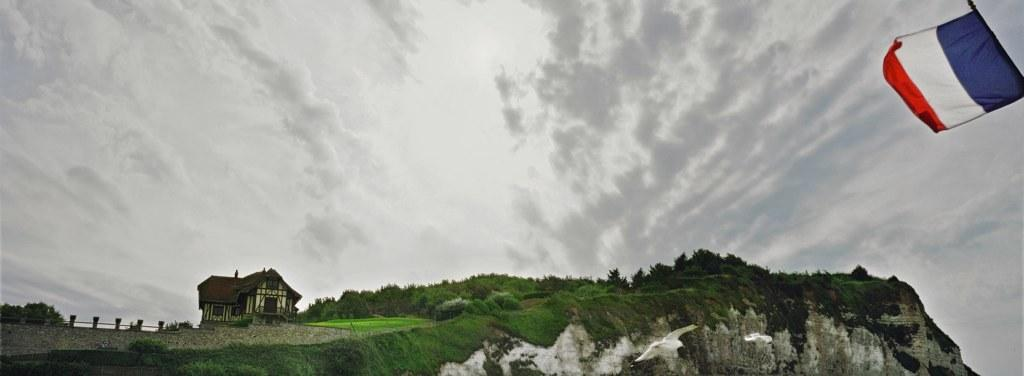What type of structure can be seen in the image? There is a building in the image. What type of vegetation is present in the image? There is grass, trees, and a mountain in the image. What type of barrier is visible in the image? There is a fence in the image. What symbol of a country is present in the image? The flag of a country is present in the image. What large object can be seen in the image? There is a big stone in the image. What is the condition of the sky in the image? The sky is cloudy in the image. What type of lead can be seen in the image? There is no lead present in the image. What type of print can be seen on the flag in the image? The flag in the image has a specific design or pattern, but it is not a print. 